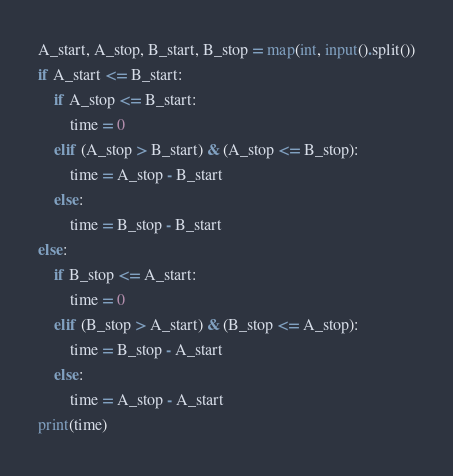Convert code to text. <code><loc_0><loc_0><loc_500><loc_500><_Python_>A_start, A_stop, B_start, B_stop = map(int, input().split())
if A_start <= B_start:
    if A_stop <= B_start:
        time = 0
    elif (A_stop > B_start) & (A_stop <= B_stop):
        time = A_stop - B_start
    else:
        time = B_stop - B_start
else:
    if B_stop <= A_start:
        time = 0
    elif (B_stop > A_start) & (B_stop <= A_stop):
        time = B_stop - A_start
    else:
        time = A_stop - A_start
print(time)</code> 